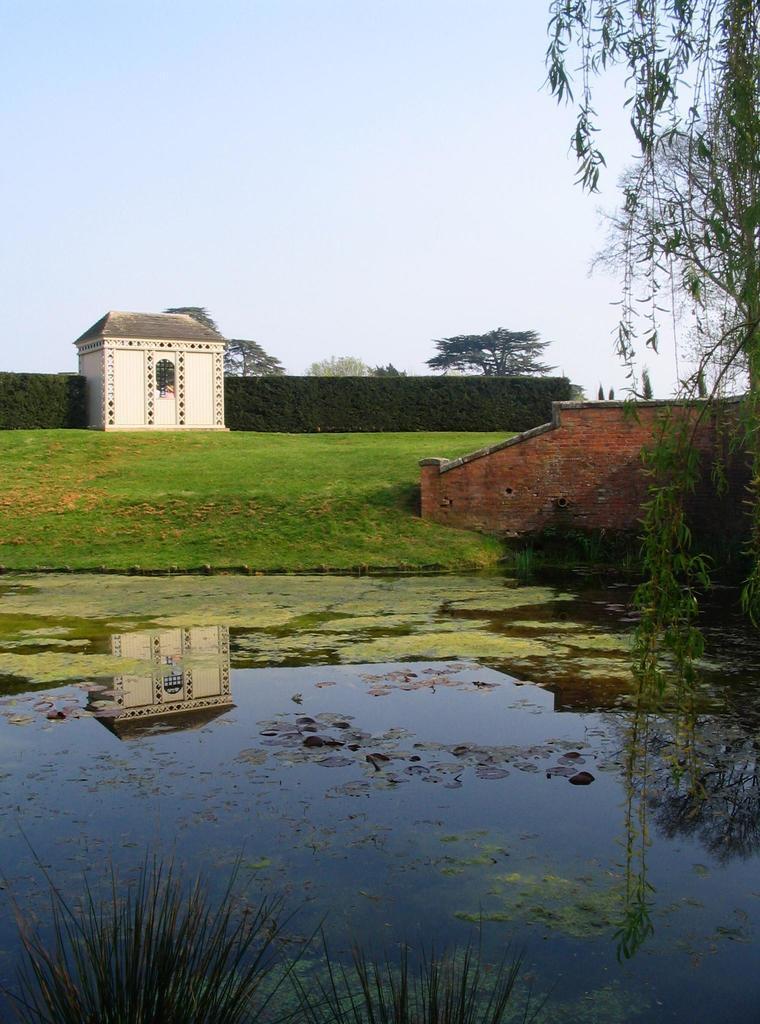Describe this image in one or two sentences. In this image we can see sky, creepers, trees, bushes, building, groundwater and duckweed on the water. 